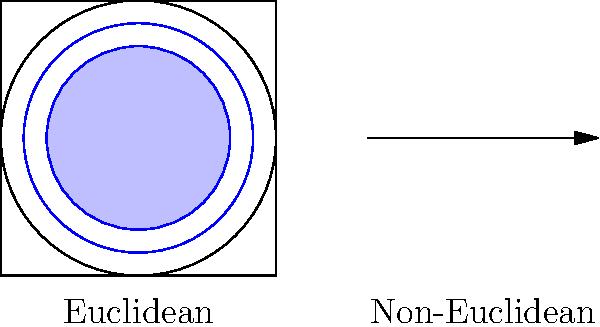As a product manager collaborating with the IT project manager on a data visualization tool, you need to explain the difference between circle areas in Euclidean and non-Euclidean geometry. If a circle with radius $r$ has area $A_E = \pi r^2$ in Euclidean geometry, and area $A_H = 4\pi \sinh^2(\frac{r}{2})$ in hyperbolic geometry (a type of non-Euclidean geometry), what is the ratio of $\frac{A_H}{A_E}$ as $r$ approaches 0? To find the ratio of the areas as $r$ approaches 0, we need to follow these steps:

1) First, let's recall the given formulas:
   Euclidean area: $A_E = \pi r^2$
   Hyperbolic area: $A_H = 4\pi \sinh^2(\frac{r}{2})$

2) We need to calculate $\lim_{r \to 0} \frac{A_H}{A_E}$:

   $\lim_{r \to 0} \frac{A_H}{A_E} = \lim_{r \to 0} \frac{4\pi \sinh^2(\frac{r}{2})}{\pi r^2}$

3) Simplify:
   $\lim_{r \to 0} \frac{4 \sinh^2(\frac{r}{2})}{r^2}$

4) Recall the Taylor series expansion of $\sinh(x)$ near 0:
   $\sinh(x) = x + \frac{x^3}{3!} + \frac{x^5}{5!} + ...$

5) For small $x$, $\sinh(x) \approx x$. Therefore, as $r$ approaches 0:
   $\sinh^2(\frac{r}{2}) \approx (\frac{r}{2})^2 = \frac{r^2}{4}$

6) Substituting this approximation:
   $\lim_{r \to 0} \frac{4 (\frac{r^2}{4})}{r^2} = \lim_{r \to 0} \frac{r^2}{r^2} = 1$

Therefore, as $r$ approaches 0, the ratio of the hyperbolic area to the Euclidean area approaches 1.
Answer: 1 